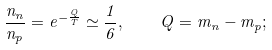<formula> <loc_0><loc_0><loc_500><loc_500>\frac { n _ { n } } { n _ { p } } = e ^ { - \frac { Q } { T } } \simeq \frac { 1 } { 6 } , \quad Q = m _ { n } - m _ { p } ;</formula> 